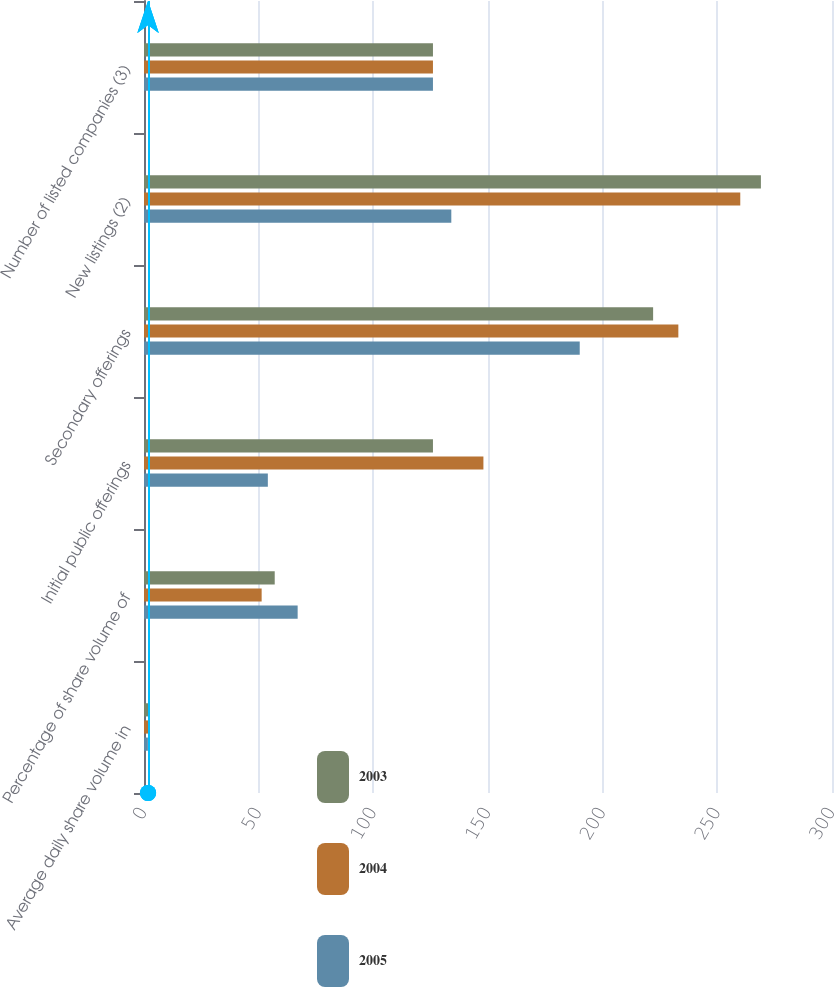Convert chart to OTSL. <chart><loc_0><loc_0><loc_500><loc_500><stacked_bar_chart><ecel><fcel>Average daily share volume in<fcel>Percentage of share volume of<fcel>Initial public offerings<fcel>Secondary offerings<fcel>New listings (2)<fcel>Number of listed companies (3)<nl><fcel>2003<fcel>1.8<fcel>57<fcel>126<fcel>222<fcel>269<fcel>126<nl><fcel>2004<fcel>1.81<fcel>51.3<fcel>148<fcel>233<fcel>260<fcel>126<nl><fcel>2005<fcel>1.69<fcel>67<fcel>54<fcel>190<fcel>134<fcel>126<nl></chart> 